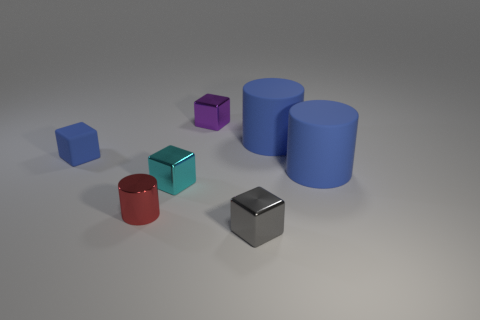How many objects are tiny metal things behind the small gray block or small gray shiny cylinders?
Give a very brief answer. 3. There is a metallic cylinder; is it the same color as the rubber thing left of the tiny gray metallic cube?
Keep it short and to the point. No. Is there a blue metal sphere of the same size as the cyan shiny cube?
Provide a succinct answer. No. There is a big cylinder behind the blue rubber object left of the cyan object; what is it made of?
Your answer should be very brief. Rubber. What number of big matte things have the same color as the small cylinder?
Offer a very short reply. 0. There is a tiny purple object that is the same material as the tiny cyan block; what is its shape?
Your answer should be compact. Cube. What size is the red shiny thing that is right of the rubber cube?
Provide a succinct answer. Small. Is the number of tiny metal objects that are on the left side of the tiny red cylinder the same as the number of red shiny cylinders on the left side of the purple shiny thing?
Keep it short and to the point. No. The large rubber object behind the big blue cylinder in front of the large cylinder that is behind the small blue rubber thing is what color?
Make the answer very short. Blue. What number of rubber things are behind the blue cube and left of the gray block?
Make the answer very short. 0. 